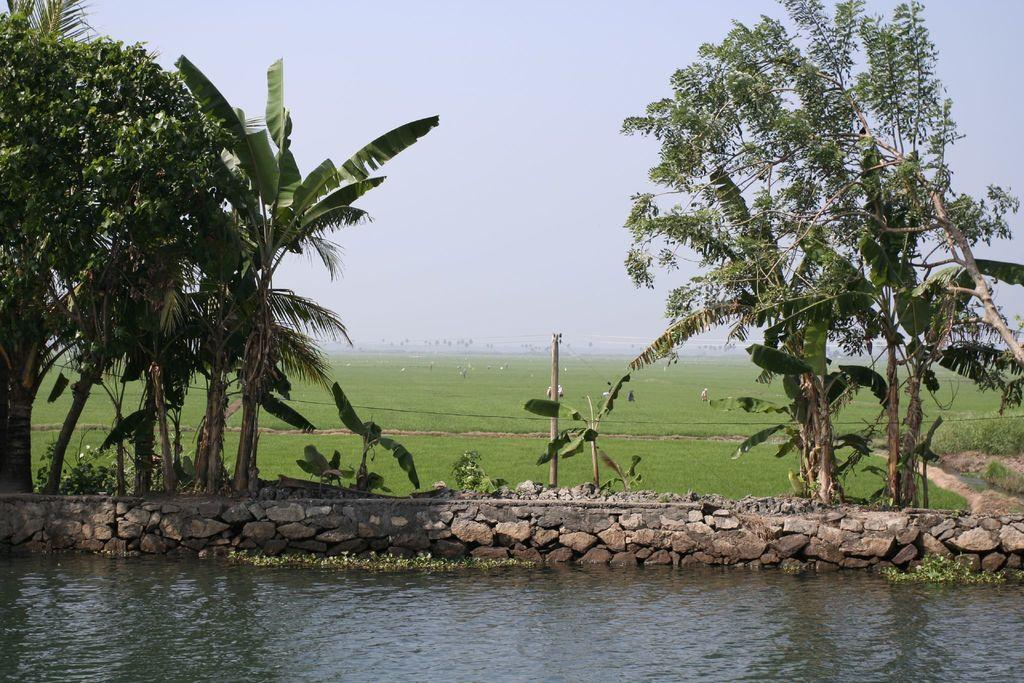What is the primary element in the picture? There is water in the picture. Are there any living beings present in the image? Yes, there are people in the picture. What type of natural vegetation can be seen in the image? There are trees in the picture. What part of the natural environment is visible in the background of the image? The sky is visible in the background of the picture. What type of flesh can be seen hanging from the trees in the image? There is no flesh hanging from the trees in the image; it features water, people, trees, and the sky. 